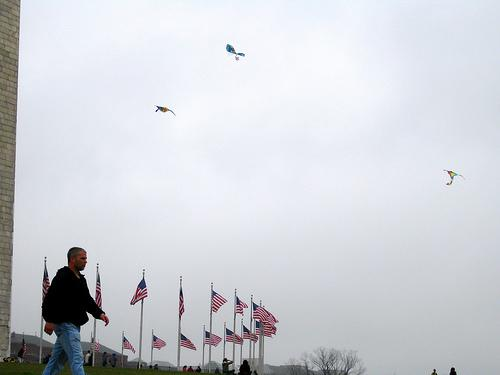Question: what type of pants is the man wearing?
Choices:
A. Chino's.
B. Khakis.
C. Capri's.
D. Jeans.
Answer with the letter. Answer: D Question: what flag is in the picture?
Choices:
A. Chinese.
B. Ireland.
C. Jewish.
D. American.
Answer with the letter. Answer: D Question: what are the flags attached to?
Choices:
A. Flag pole.
B. Rope.
C. Ceiling.
D. Plastic holders.
Answer with the letter. Answer: A Question: what color top is the man wearing?
Choices:
A. Black.
B. Brown.
C. White.
D. Blue.
Answer with the letter. Answer: A 